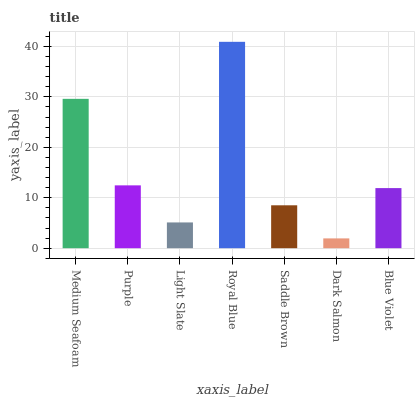Is Dark Salmon the minimum?
Answer yes or no. Yes. Is Royal Blue the maximum?
Answer yes or no. Yes. Is Purple the minimum?
Answer yes or no. No. Is Purple the maximum?
Answer yes or no. No. Is Medium Seafoam greater than Purple?
Answer yes or no. Yes. Is Purple less than Medium Seafoam?
Answer yes or no. Yes. Is Purple greater than Medium Seafoam?
Answer yes or no. No. Is Medium Seafoam less than Purple?
Answer yes or no. No. Is Blue Violet the high median?
Answer yes or no. Yes. Is Blue Violet the low median?
Answer yes or no. Yes. Is Dark Salmon the high median?
Answer yes or no. No. Is Purple the low median?
Answer yes or no. No. 